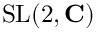<formula> <loc_0><loc_0><loc_500><loc_500>S L ( 2 , C )</formula> 